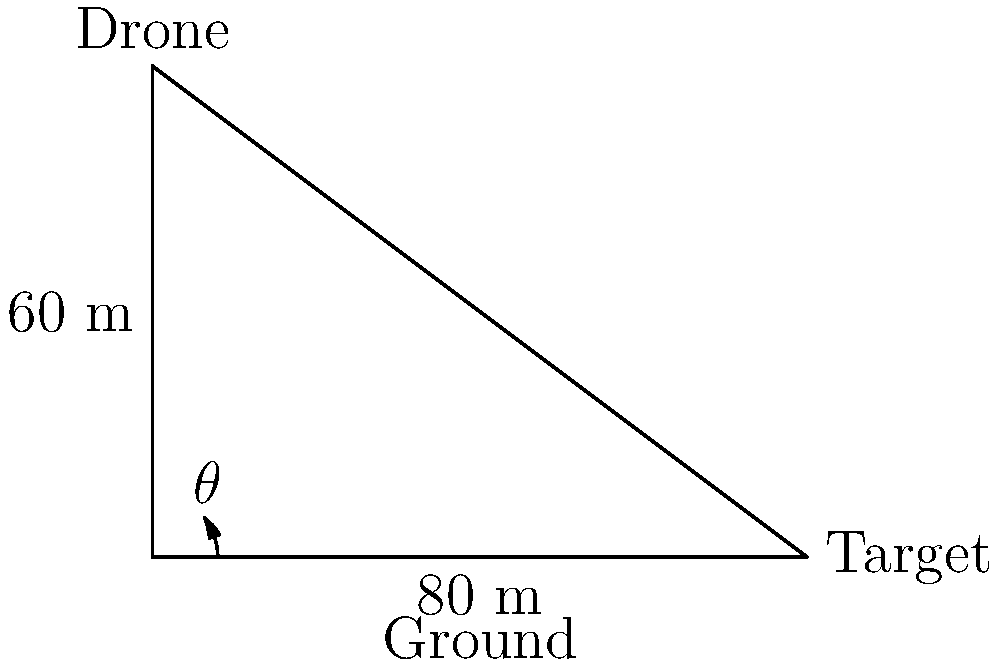For your latest aerial photography project, you need to position your drone for the perfect shot. The drone is hovering 60 meters directly above the ground, and the target is 80 meters away horizontally. What angle $\theta$ (in degrees) should the drone's camera be tilted down from the horizontal to capture the target perfectly? To solve this problem, we'll use trigonometry, specifically the arctangent function. Here's the step-by-step solution:

1) We have a right triangle with:
   - Adjacent side (horizontal distance) = 80 meters
   - Opposite side (vertical height) = 60 meters

2) We need to find the angle $\theta$ that the hypotenuse (line of sight from drone to target) makes with the horizontal.

3) In a right triangle, $\tan(\theta) = \frac{\text{opposite}}{\text{adjacent}}$

4) Substituting our values:
   $\tan(\theta) = \frac{60}{80} = \frac{3}{4} = 0.75$

5) To find $\theta$, we need to use the inverse tangent (arctangent) function:
   $\theta = \arctan(0.75)$

6) Using a calculator or mathematical software:
   $\theta \approx 36.87°$

Therefore, the drone's camera should be tilted down approximately 36.87° from the horizontal.
Answer: $36.87°$ 